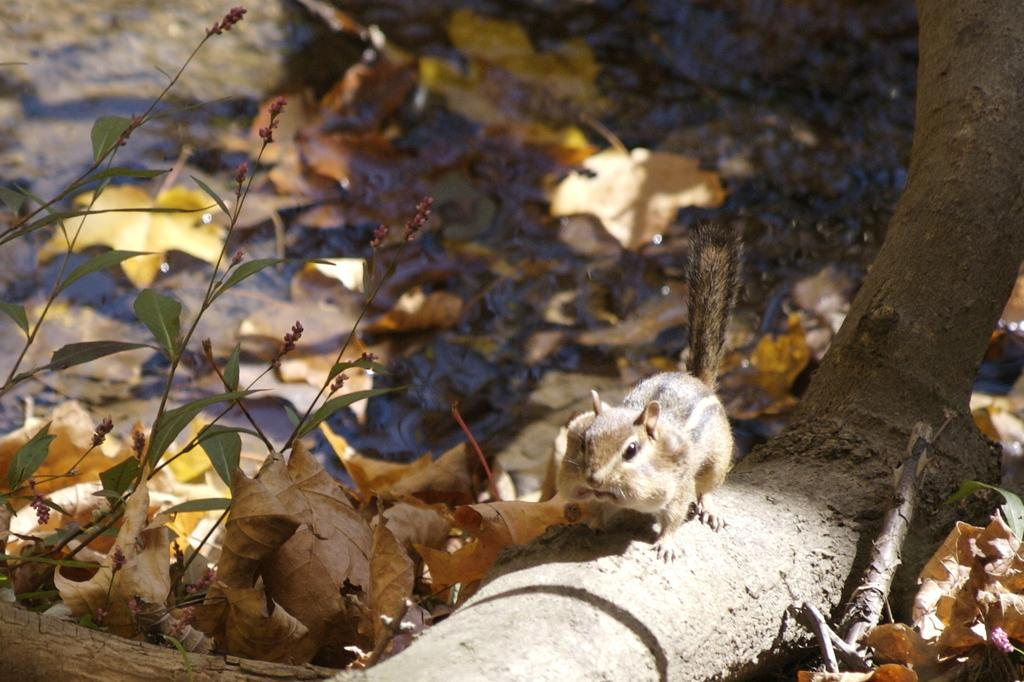What animal can be seen in the image? There is a squirrel on a tree trunk in the image. What is on the ground in the image? There are dried leaves on the ground in the image. What type of vegetation is present in the image? There are plants in the image. What type of dinner is the squirrel preparing in the image? There is no indication in the image that the squirrel is preparing a dinner, as squirrels do not cook or prepare meals. 